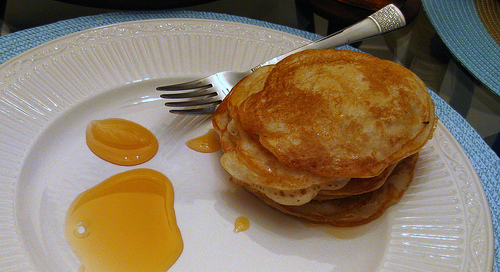<image>
Is the placemat under the pancake? Yes. The placemat is positioned underneath the pancake, with the pancake above it in the vertical space. 